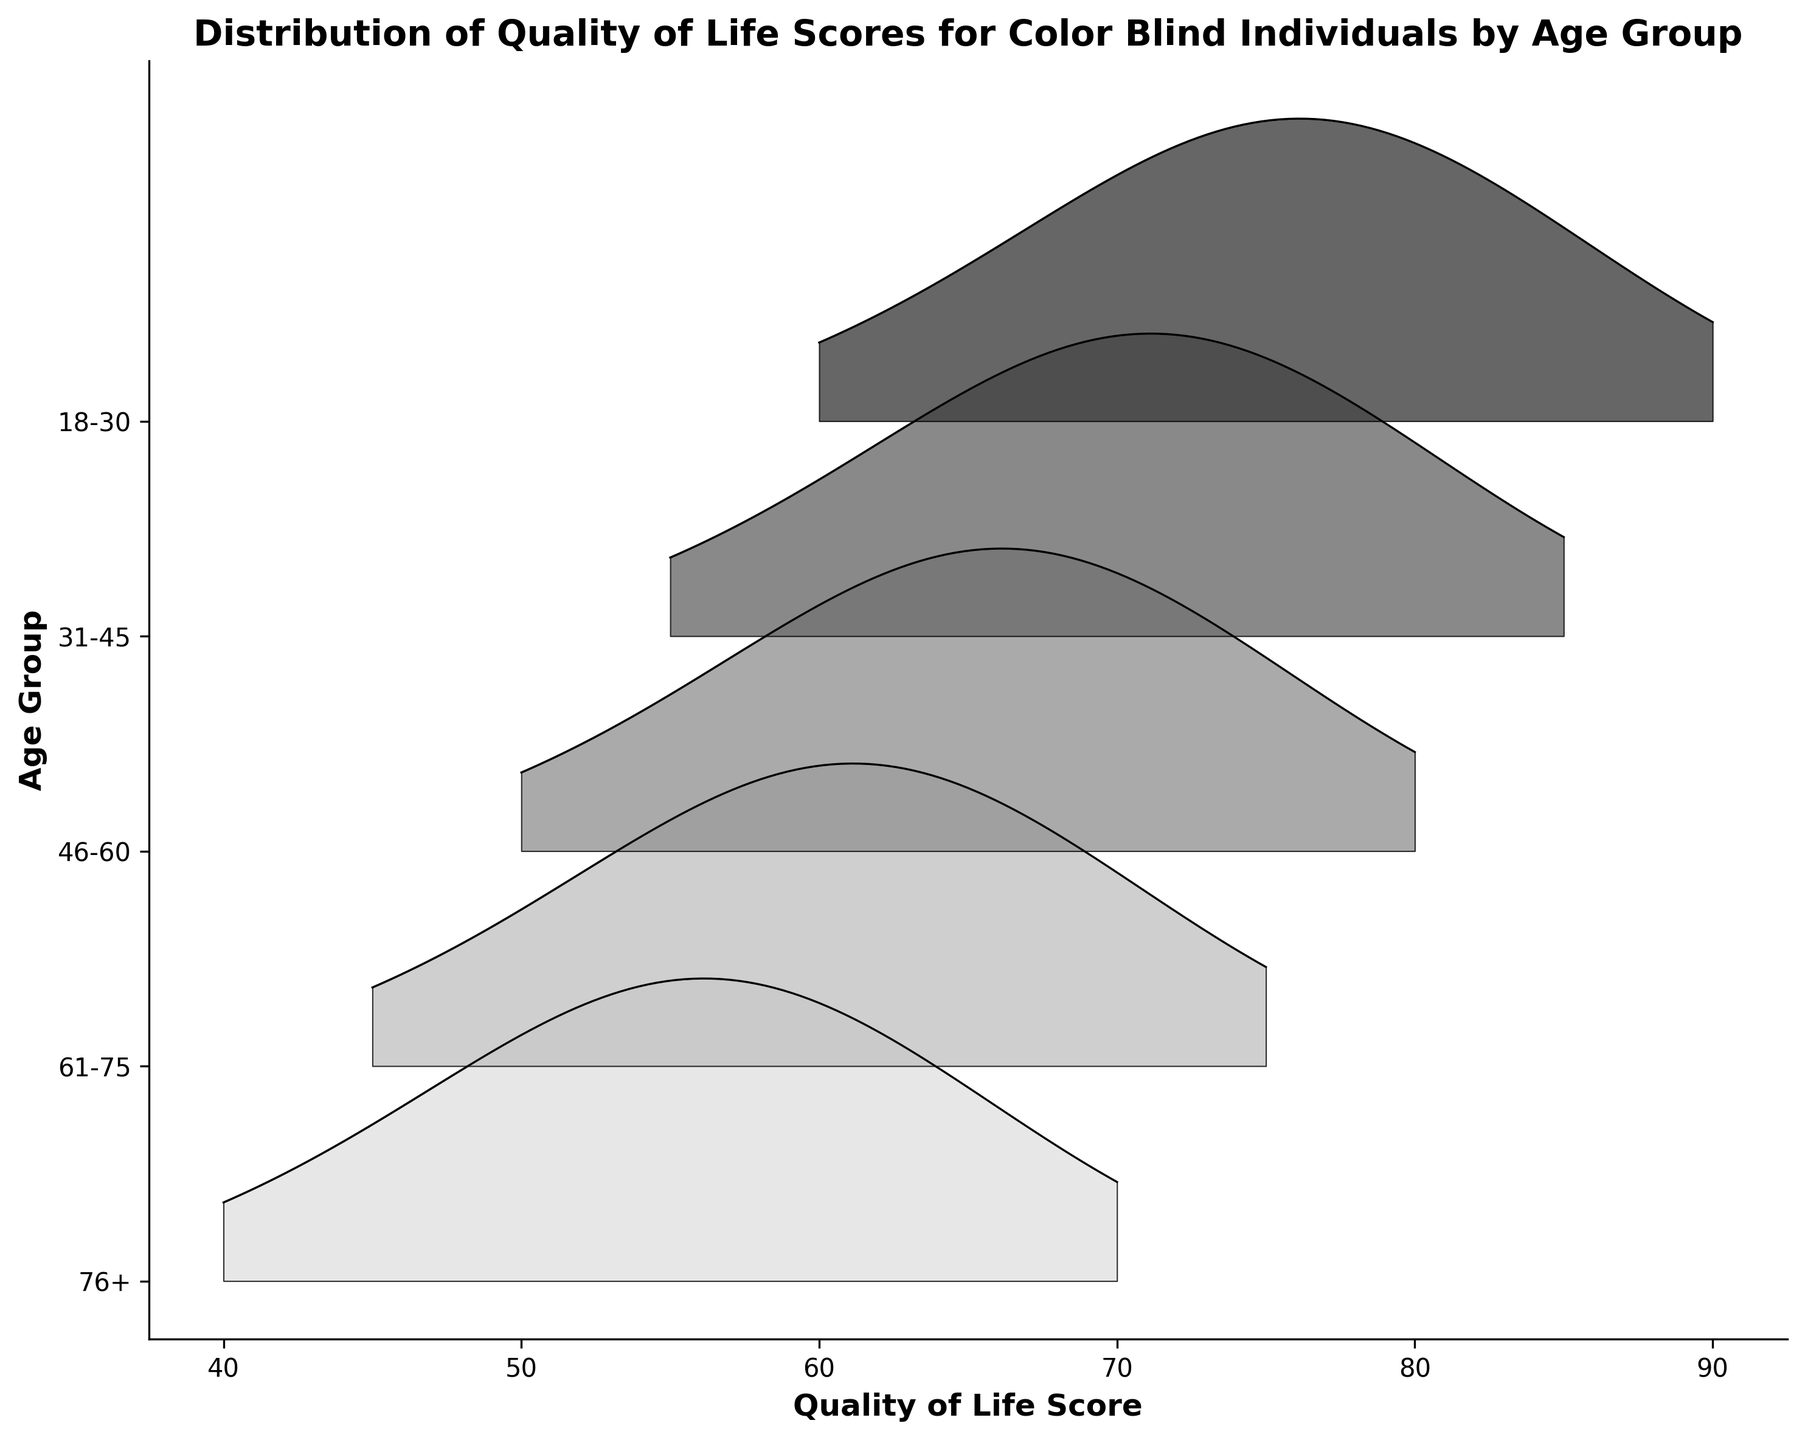How many age groups are represented in the plot? By examining the y-axis, we can see the distinct labels representing different age groups. Counting these labels allows us to determine the number of age groups.
Answer: 5 Which age group has the highest median Quality of Life Score? To determine this, find the age group whose distribution is centered around the highest score. The median value is typically located near the peak of the distribution.
Answer: 18-30 What is the range of Quality of Life Scores for the 76+ age group? By observing the horizontal spread of the density plot for the 76+ age group, we can see the range from the minimum to the maximum scores.
Answer: 40-70 Which age group has the lowest peak density in the distribution? The lowest peak density corresponds to the smallest peak height among the distributions. Identify the age group's plot with the lowest peak.
Answer: 76+ How does the range of scores for the 31-45 age group compare to that of the 61-75 age group? By examining the horizontal range covered by each group's distribution, notice if they overlap or shift indicating a wider or narrower range. The 31-45 group spans scores from 55 to 85, while the 61-75 group ranges from 45 to 75.
Answer: 31-45 has a wider range Which age group shows the most variability in Quality of Life Scores? Variability can be interpreted by the spread of the distribution; the wider the spread, the more variability. Compare the width of the distributions of each age group.
Answer: 18-30 or 31-45 In which age group is the peak Quality of Life Score closer to the minimum end of the score range? Look for the distribution peaks near the lower end of their respective ranges. The 76+ group has a peak near the minimum score.
Answer: 76+ Compare the central tendency of Quality of Life Scores between the 18-30 and 46-60 age groups. Central tendency can be observed from the peak positions of the distributions. Identify the relative positions of these peaks along the score axis.
Answer: 18-30 is higher than 46-60 What insight can be derived about Quality of Life Scores as age increases? Observing the trend from youngest to oldest groups, note changes in peak positions, ranges, and density shapes. The general insight is a decrease in scores with age. *Provide detailed reasoning*: As age increases from 18-30 to 76+, the peak shifts to the left, indicating lower scores, and the spread narrows, suggesting reduced variability.
Answer: Scores tend to decrease with age 